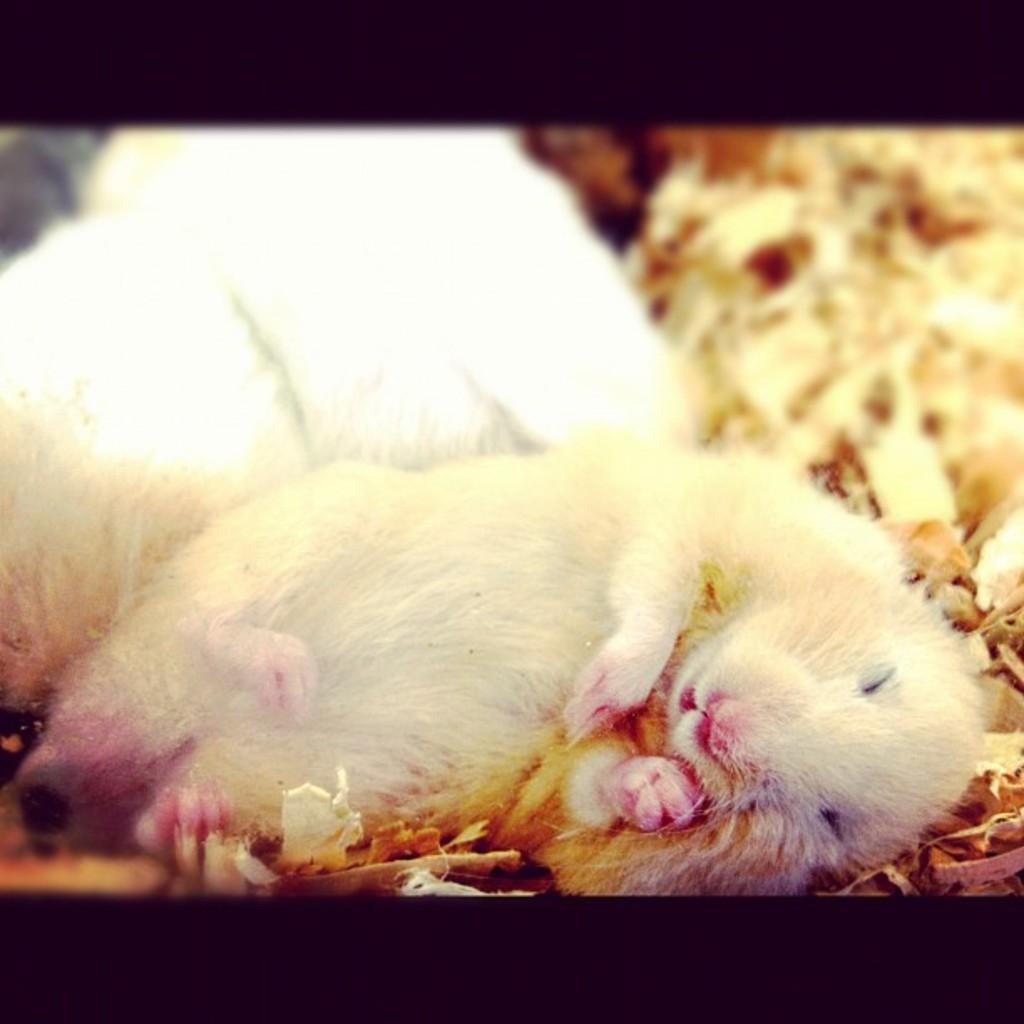Describe this image in one or two sentences. In this image, we can see two rats and some objects. Background there is a blur view. At the top and bottom of the image, we can see black color borders. 